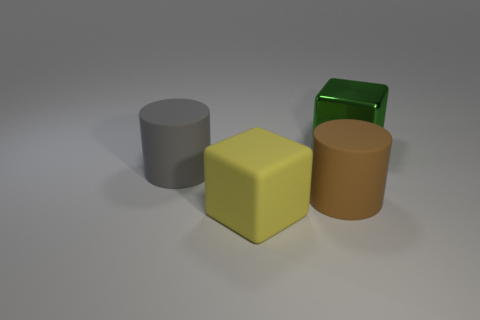Is there any indication of the size of these objects relative to one another? There is no direct reference for scale, but relative to each other, the objects' sizes can be compared. In the context of the image, the yellow cube looks to be the largest in volume, followed by the brown object and the gray cylinder, which seem similar in width but differ in height. The green object appears to be the smallest, both in height and volume. 